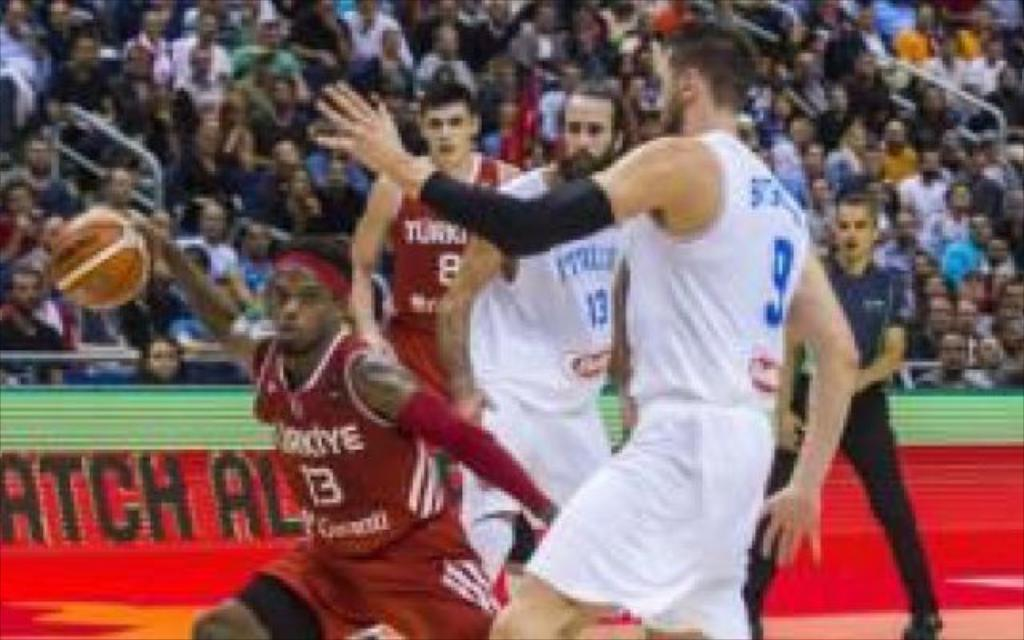What sport are the players engaged in within the image? The players are playing basketball in the image. What can be seen in the background of the image? There is an audience in the background of the image. What are the members of the audience doing? The audience is sitting and watching the basketball game. What type of hat is the oven wearing in the image? There is no oven or hat present in the image. 